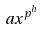Convert formula to latex. <formula><loc_0><loc_0><loc_500><loc_500>a x ^ { p ^ { h } }</formula> 